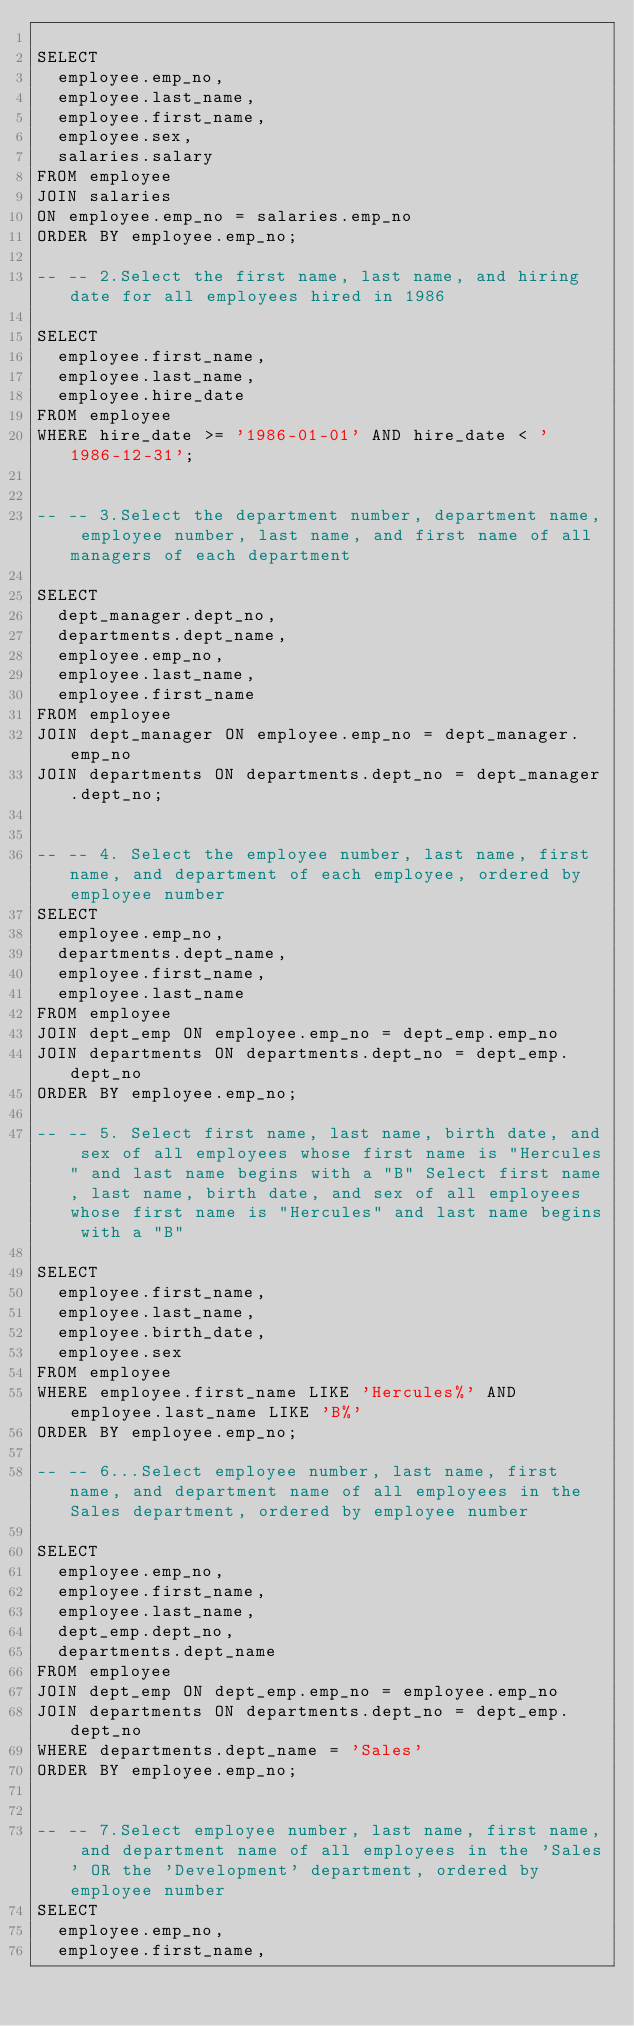<code> <loc_0><loc_0><loc_500><loc_500><_SQL_> 
SELECT
  employee.emp_no,
  employee.last_name,
  employee.first_name,
  employee.sex,
  salaries.salary
FROM employee
JOIN salaries
ON employee.emp_no = salaries.emp_no  
ORDER BY employee.emp_no;
 
-- -- 2.Select the first name, last name, and hiring date for all employees hired in 1986

SELECT
  employee.first_name,
  employee.last_name,
  employee.hire_date
FROM employee
WHERE hire_date >= '1986-01-01' AND hire_date < '1986-12-31';


-- -- 3.Select the department number, department name, employee number, last name, and first name of all managers of each department

SELECT
  dept_manager.dept_no,
  departments.dept_name,
  employee.emp_no,
  employee.last_name,
  employee.first_name
FROM employee
JOIN dept_manager ON employee.emp_no = dept_manager.emp_no
JOIN departments ON departments.dept_no = dept_manager.dept_no;


-- -- 4. Select the employee number, last name, first name, and department of each employee, ordered by employee number
SELECT
  employee.emp_no,
  departments.dept_name,
  employee.first_name,
  employee.last_name
FROM employee
JOIN dept_emp ON employee.emp_no = dept_emp.emp_no 
JOIN departments ON departments.dept_no = dept_emp.dept_no
ORDER BY employee.emp_no;

-- -- 5. Select first name, last name, birth date, and sex of all employees whose first name is "Hercules" and last name begins with a "B" Select first name, last name, birth date, and sex of all employees whose first name is "Hercules" and last name begins with a "B"

SELECT
  employee.first_name,
  employee.last_name,
  employee.birth_date,
  employee.sex
FROM employee
WHERE employee.first_name LIKE 'Hercules%' AND employee.last_name LIKE 'B%'
ORDER BY employee.emp_no;

-- -- 6...Select employee number, last name, first name, and department name of all employees in the Sales department, ordered by employee number

SELECT
  employee.emp_no,
  employee.first_name,
  employee.last_name,
  dept_emp.dept_no,
  departments.dept_name
FROM employee
JOIN dept_emp ON dept_emp.emp_no = employee.emp_no
JOIN departments ON departments.dept_no = dept_emp.dept_no
WHERE departments.dept_name = 'Sales'
ORDER BY employee.emp_no;


-- -- 7.Select employee number, last name, first name, and department name of all employees in the 'Sales' OR the 'Development' department, ordered by employee number
SELECT
  employee.emp_no,
  employee.first_name,</code> 